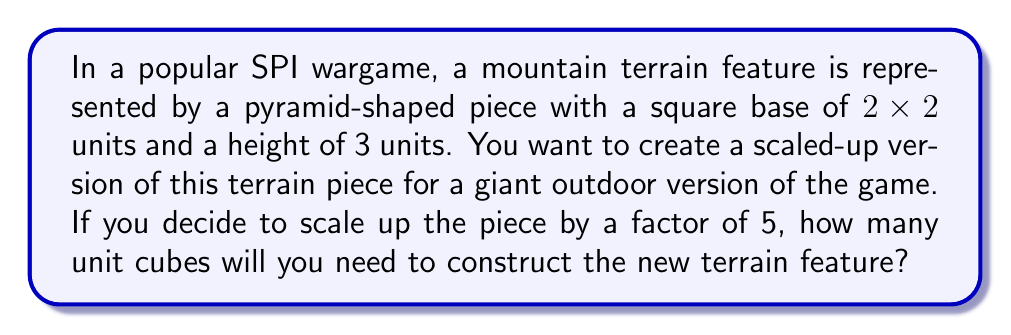Help me with this question. Let's approach this step-by-step:

1) First, let's understand the original dimensions:
   - Base: 2x2 units
   - Height: 3 units

2) Now, we're scaling up by a factor of 5. This means:
   - New base: 10x10 units (5 times 2x2)
   - New height: 15 units (5 times 3)

3) The shape we're dealing with is a square pyramid. The volume of a square pyramid is given by the formula:

   $$V = \frac{1}{3} * B * h$$

   Where $B$ is the area of the base and $h$ is the height.

4) Let's calculate:
   - Base area: $B = 10 * 10 = 100$ square units
   - Height: $h = 15$ units

5) Plugging into our formula:

   $$V = \frac{1}{3} * 100 * 15 = 500$$ cubic units

6) However, we need to count the number of unit cubes. Since we can't have fractional cubes, we need to round up to the nearest whole number.

[asy]
import three;
size(200);
currentprojection=perspective(6,3,2);
draw(unitcube,opacity(0.1));
draw((0,0,0)--(10,0,0)--(10,10,0)--(0,10,0)--cycle);
draw((0,0,0)--(5,5,15)--(10,0,0));
draw((0,10,0)--(5,5,15)--(10,10,0));
label("15",(5,5,7.5),E);
label("10",(5,0,0),S);
label("10",(0,5,0),W);
[/asy]
Answer: 500 unit cubes 